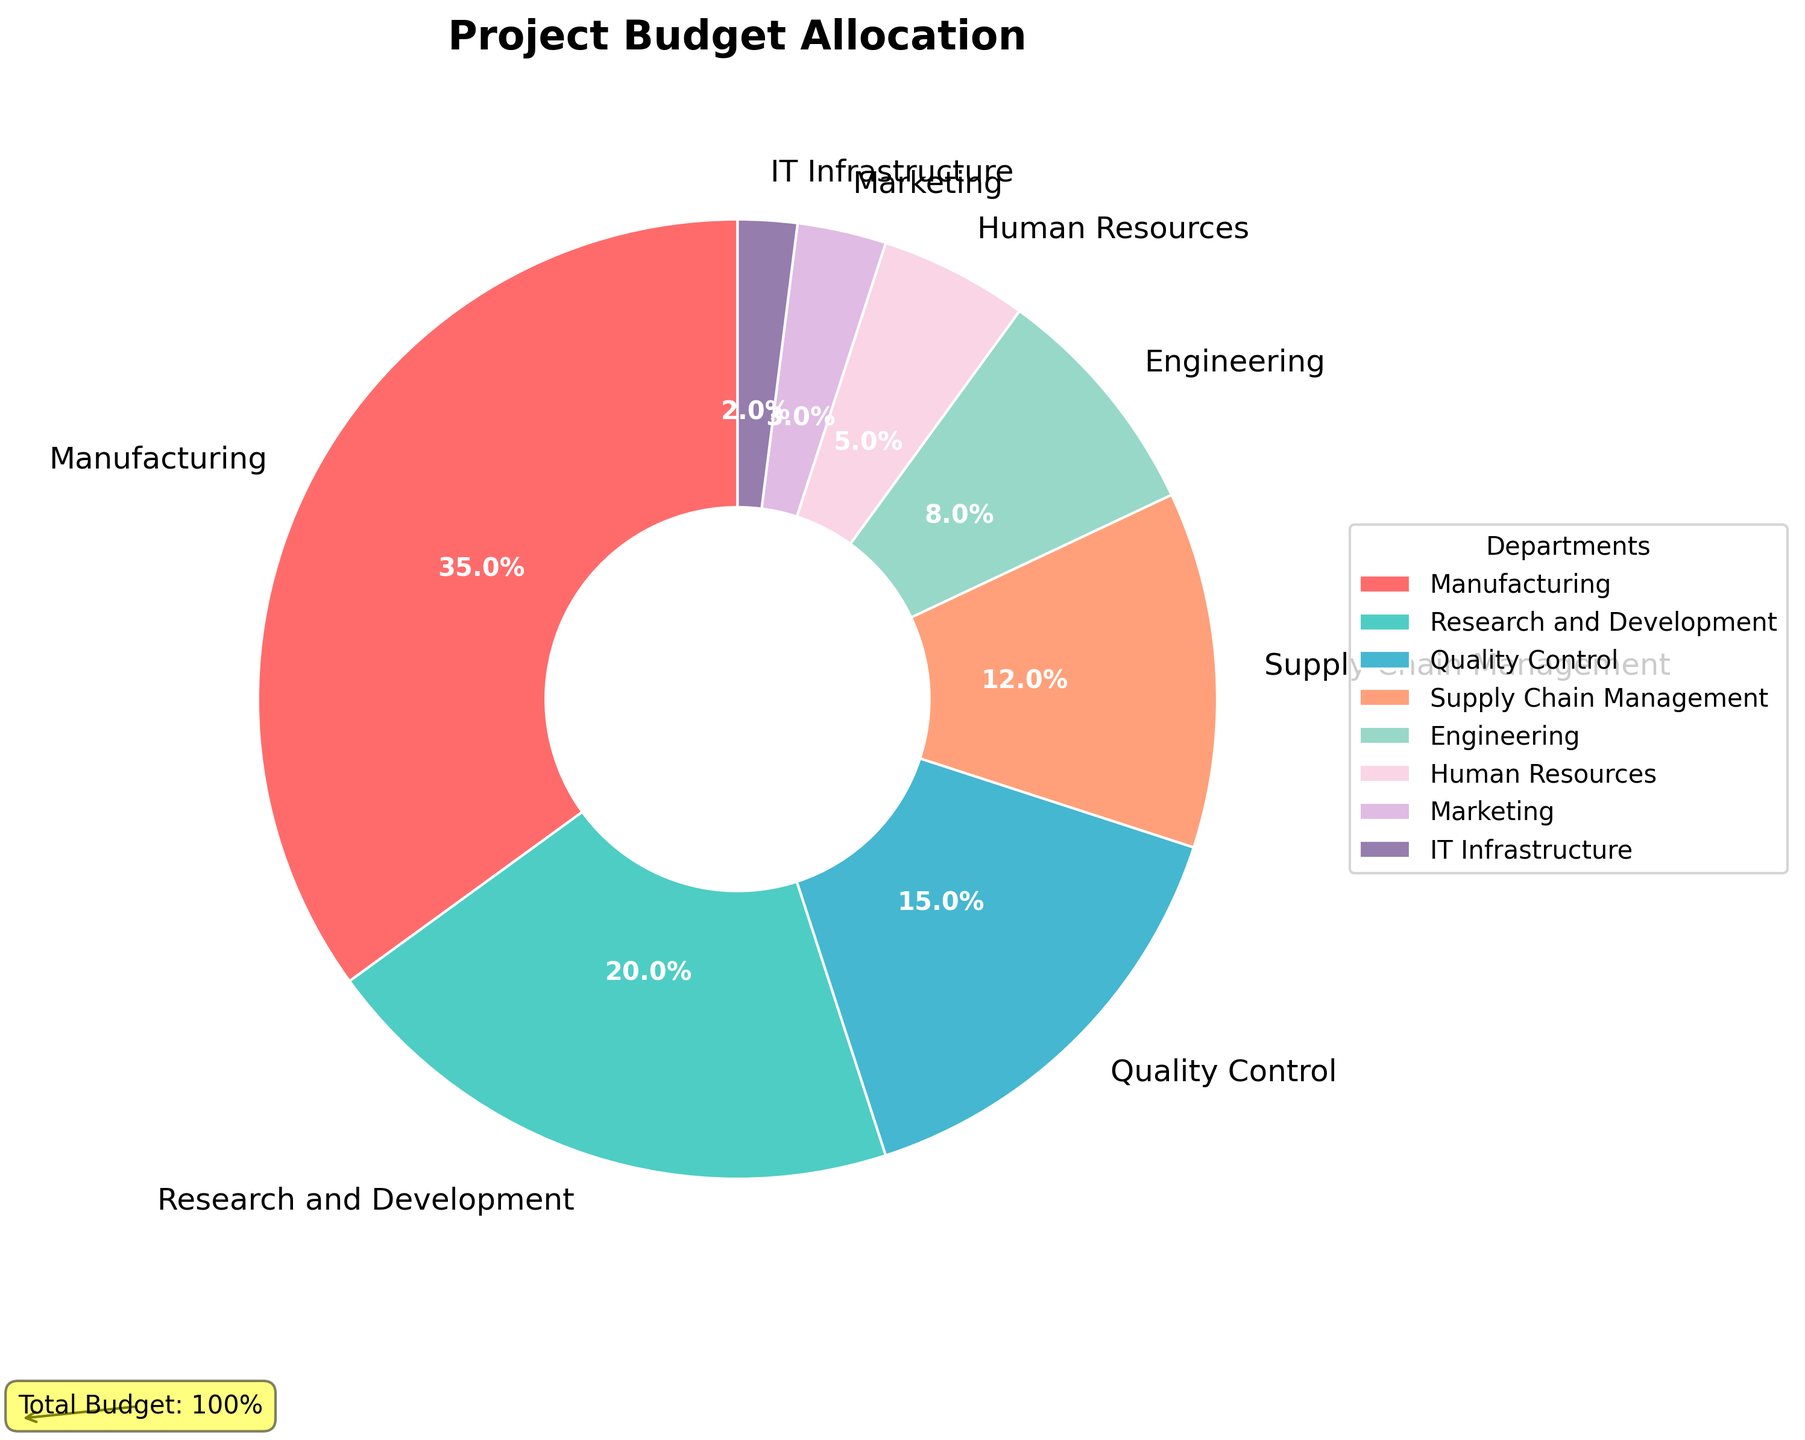What percentage of the budget is allocated to Manufacturing? From the pie chart, Manufacturing has a label indicating 35%, which represents its share of the total budget.
Answer: 35% Which department receives the lowest budget allocation, and what is its percentage? The pie chart shows that IT Infrastructure has the lowest allocation, and its percentage is 2%.
Answer: IT Infrastructure, 2% What is the combined budget allocation for Quality Control and Supply Chain Management? Quality Control is allocated 15% and Supply Chain Management 12%. Adding them together: 15% + 12% = 27%.
Answer: 27% How much more budget is allocated to Manufacturing compared to Engineering? Manufacturing is allocated 35%, and Engineering 8%. The difference is 35% - 8% = 27%.
Answer: 27% Which two departments have the closest budget allocations, and what are their percentages? Human Resources (5%) and Marketing (3%) are the closest, with a difference of 2%.
Answer: Human Resources (5%) and Marketing (3%) Are there more than three departments with a budget allocation below 10%? The pie chart shows that Engineering (8%), Human Resources (5%), Marketing (3%), and IT Infrastructure (2%) are below 10%. There are four departments.
Answer: Yes What is the total budget allocation for departments receiving less than 10%? Combining Engineering (8%), Human Resources (5%), Marketing (3%), and IT Infrastructure (2%): 8% + 5% + 3% + 2% = 18%.
Answer: 18% Which department is represented by the green wedge, and what is its allocation? The pie chart shows the department in green, which is Research and Development, with a 20% allocation.
Answer: Research and Development, 20% What is the ratio of the budget allocated to Manufacturing to that allocated to IT Infrastructure? Manufacturing has 35% and IT Infrastructure 2%. The ratio is 35% to 2%, simplified to 35:2 or 17.5:1.
Answer: 17.5:1 